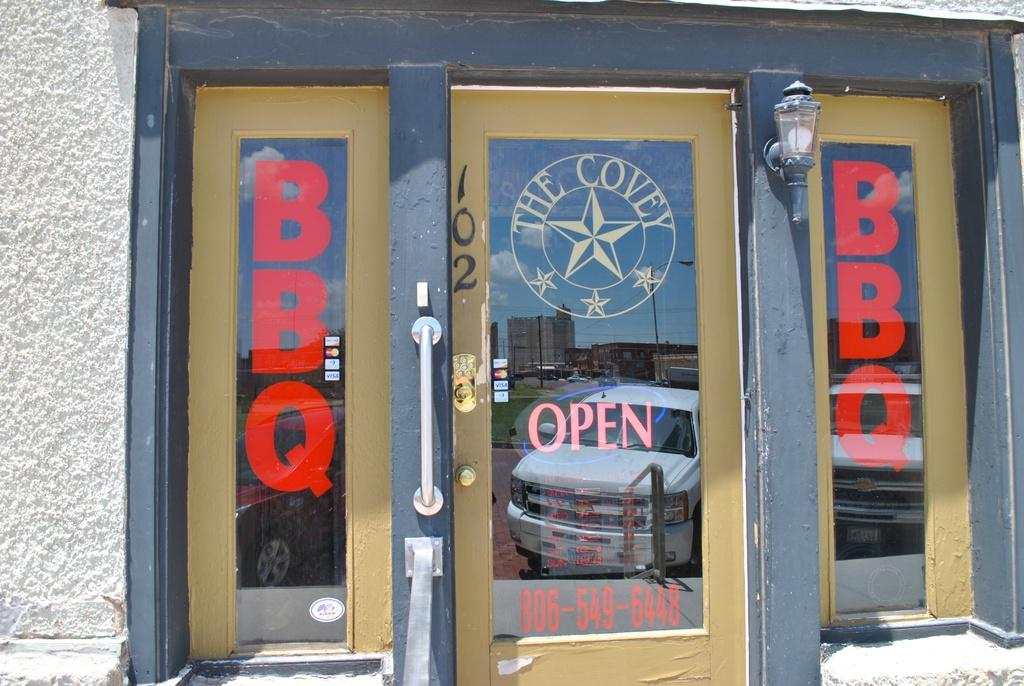What type of objects can be seen in the image that provide illumination? There are lights in the image. What type of objects can be seen in the image that allow access to different areas? There are doors in the image. What type of objects can be seen in the image that allow natural light to enter and provide a view of the outside? There are windows in the image. What type of skin can be seen on the bat in the image? There is no bat present in the image, so there is no skin to observe. 